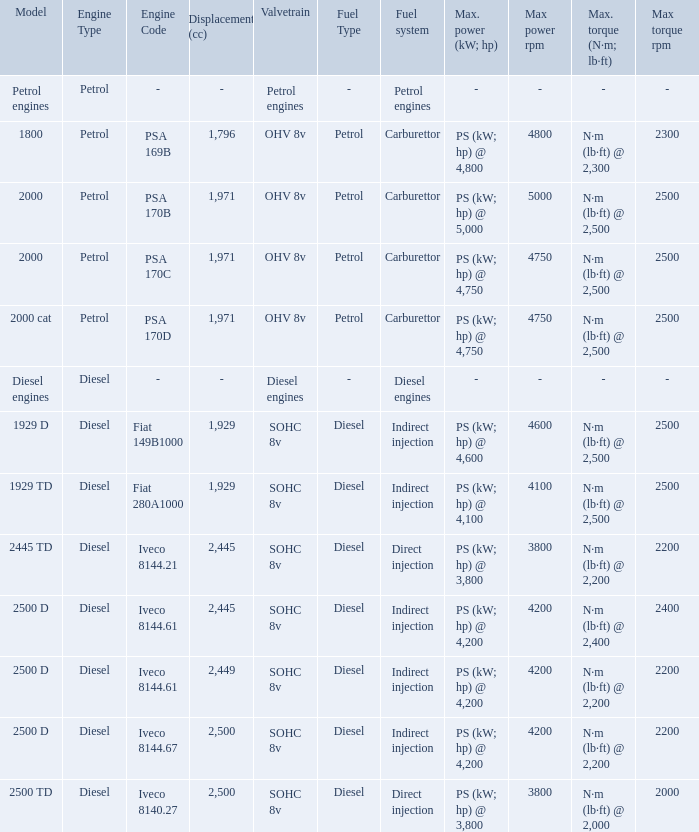What Valvetrain has a fuel system made up of petrol engines? Petrol engines. 